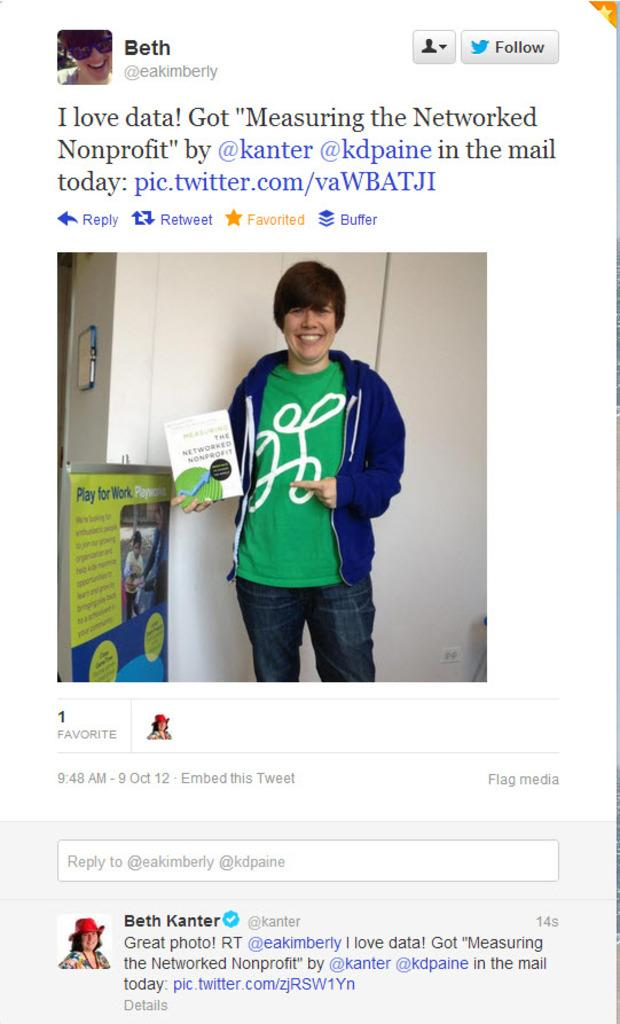<image>
Present a compact description of the photo's key features. A tweet by Beth Kanter is featured under a photo of a woman. 